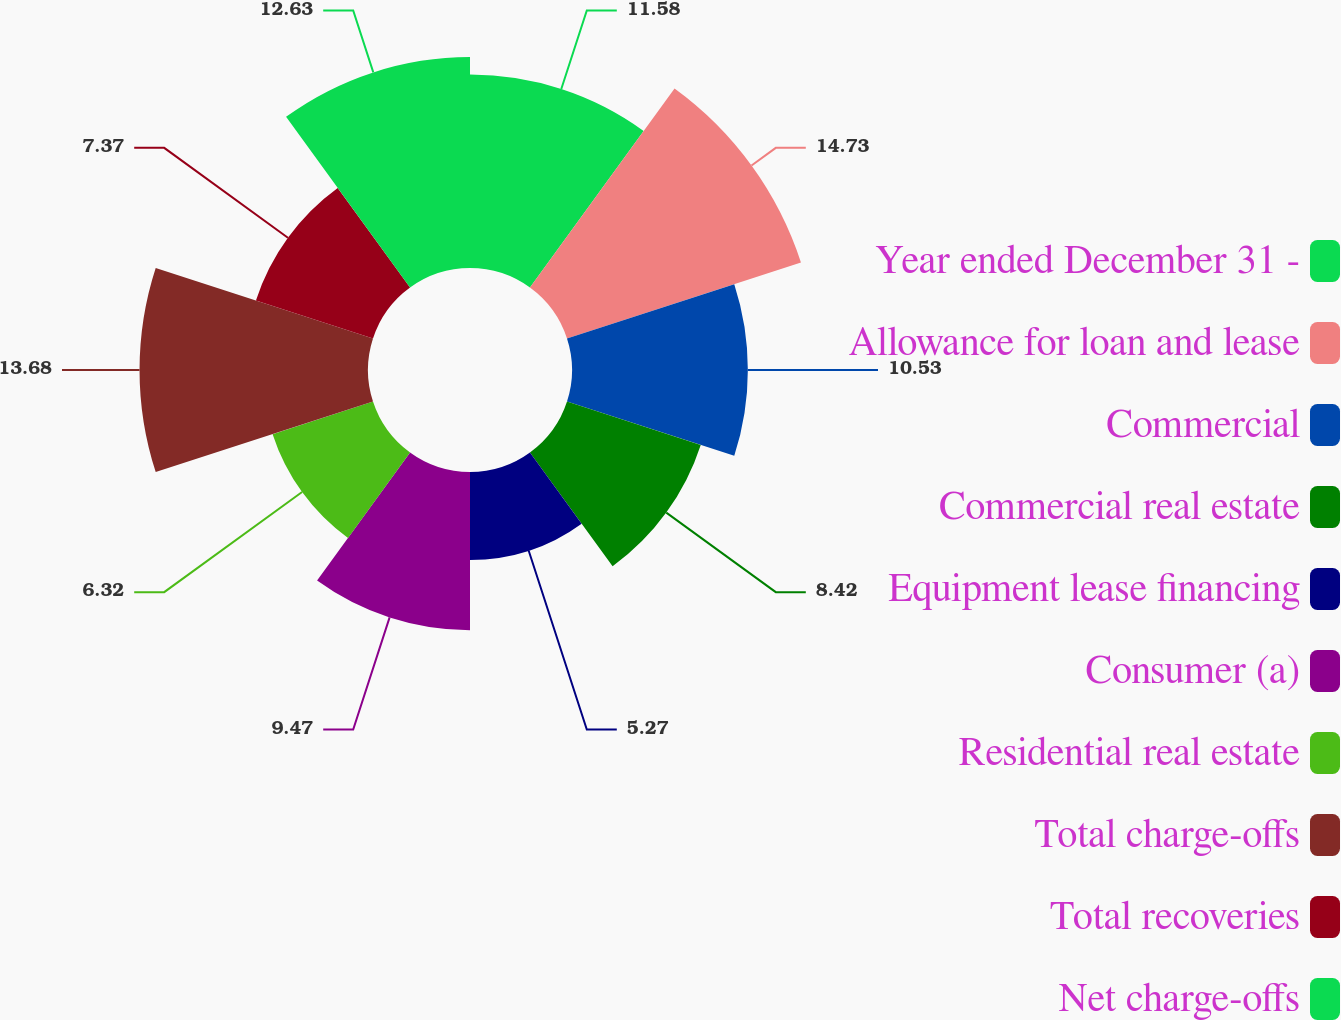<chart> <loc_0><loc_0><loc_500><loc_500><pie_chart><fcel>Year ended December 31 -<fcel>Allowance for loan and lease<fcel>Commercial<fcel>Commercial real estate<fcel>Equipment lease financing<fcel>Consumer (a)<fcel>Residential real estate<fcel>Total charge-offs<fcel>Total recoveries<fcel>Net charge-offs<nl><fcel>11.58%<fcel>14.73%<fcel>10.53%<fcel>8.42%<fcel>5.27%<fcel>9.47%<fcel>6.32%<fcel>13.68%<fcel>7.37%<fcel>12.63%<nl></chart> 